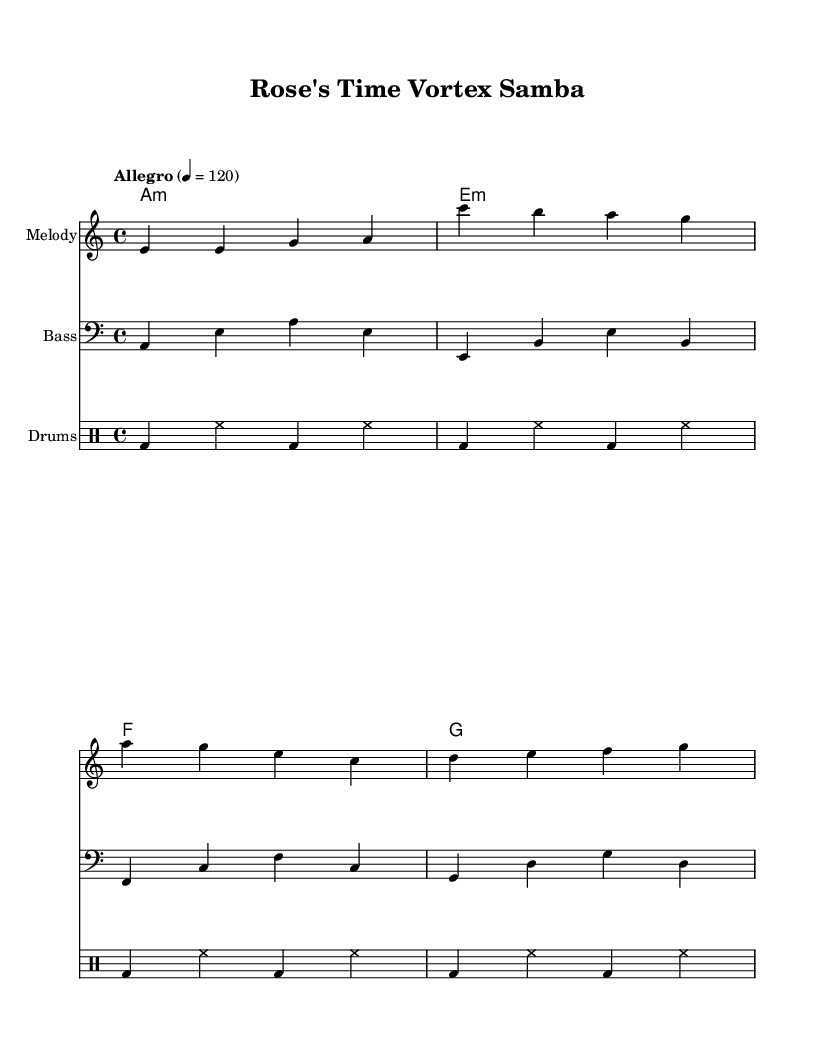What is the time signature of this music? The time signature is located at the beginning of the sheet music and indicates how many beats are in each measure. In this case, it is written as 4/4, which means there are four beats per measure.
Answer: 4/4 What is the tempo marking for this piece? The tempo marking can be found near the beginning of the score, indicating how fast the piece should be played. Here, it states "Allegro" followed by a metronome mark of 4 = 120, showing a lively tempo.
Answer: Allegro, 120 What key is the music composed in? The key signature is indicated at the start, represented by the letter in the key context. Here it shows 'a', indicating it is in the key of A minor.
Answer: A minor How many measures are in the melody part? By counting the measures in the melody line, each set of vertical lines represents a measure. The provided melody contains a total of four measures.
Answer: 4 What chord follows the E minor chord in the harmony? The harmony section lists the chords sequentially. After the E minor (e:m), the next chord listed is the F major chord.
Answer: F What type of drum pattern is used in this score? The drum pattern is shown in the drum staff section, and it consists of a repetitive bass drum (bd) and hi-hat (hh) pattern, characteristic of Latin rhythms.
Answer: Samba What is the clef used in the bass part? The clef used is indicated at the beginning of the bass staff. It states "bass", meaning this part is written for bass clef, typically for lower-pitched instruments.
Answer: Bass clef 